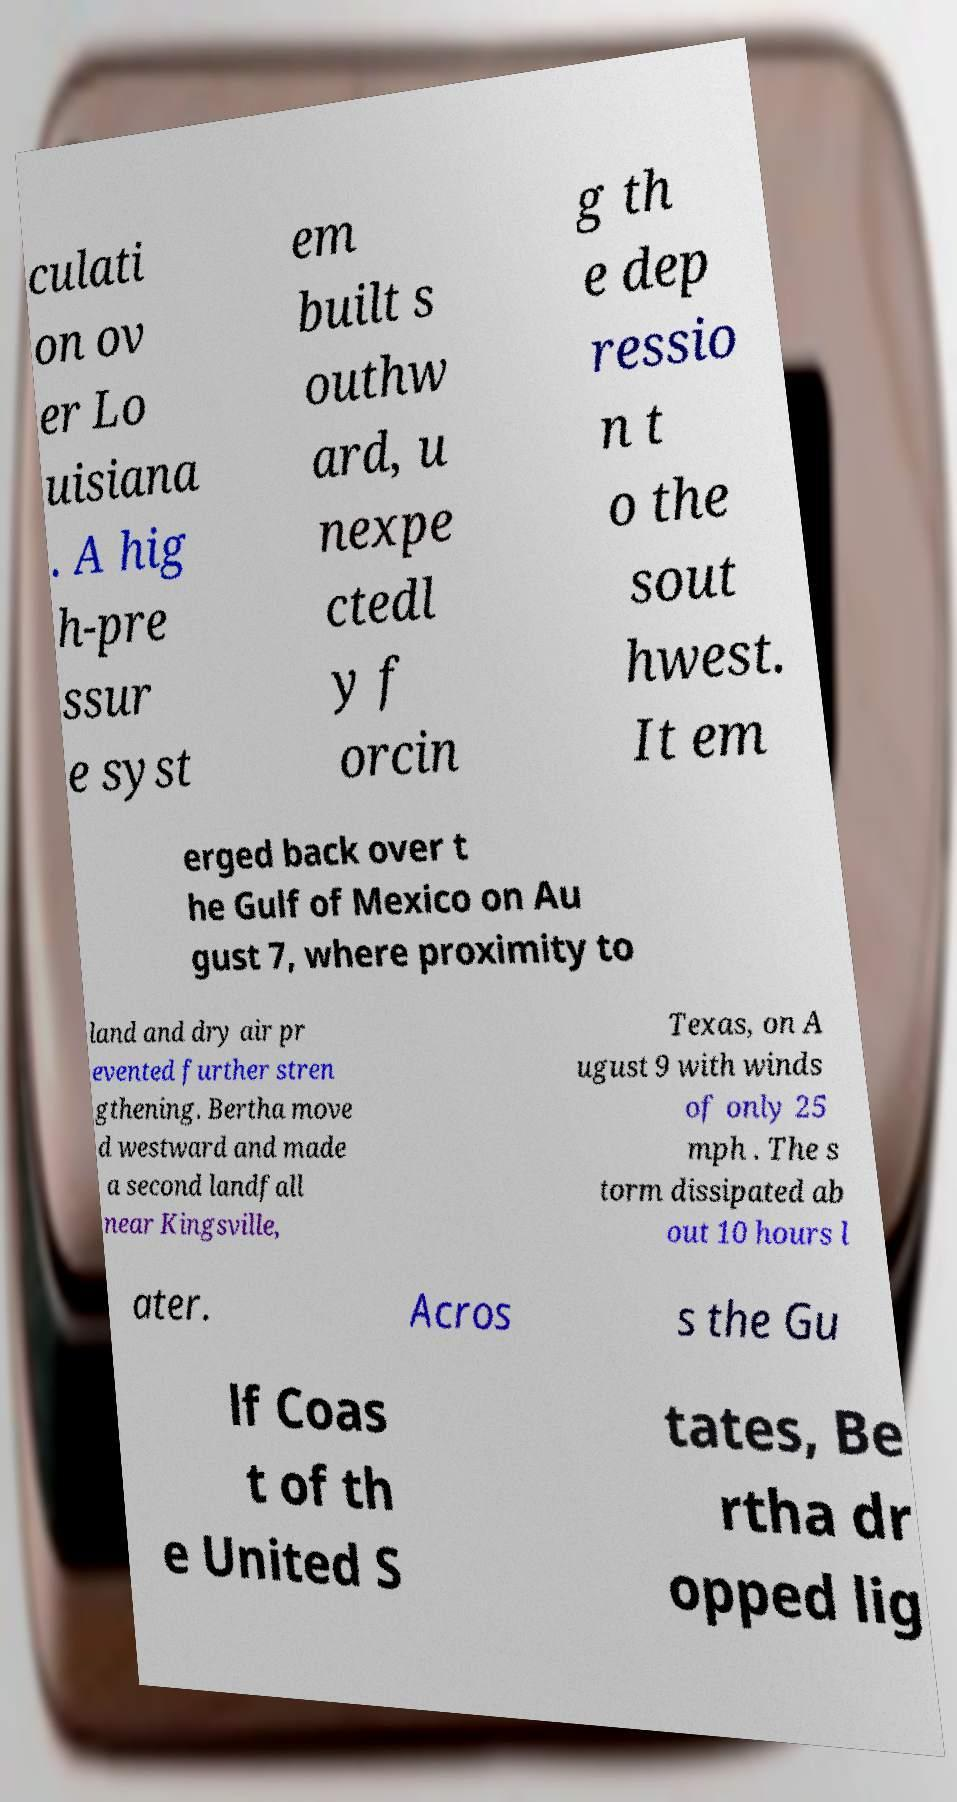What messages or text are displayed in this image? I need them in a readable, typed format. culati on ov er Lo uisiana . A hig h-pre ssur e syst em built s outhw ard, u nexpe ctedl y f orcin g th e dep ressio n t o the sout hwest. It em erged back over t he Gulf of Mexico on Au gust 7, where proximity to land and dry air pr evented further stren gthening. Bertha move d westward and made a second landfall near Kingsville, Texas, on A ugust 9 with winds of only 25 mph . The s torm dissipated ab out 10 hours l ater. Acros s the Gu lf Coas t of th e United S tates, Be rtha dr opped lig 